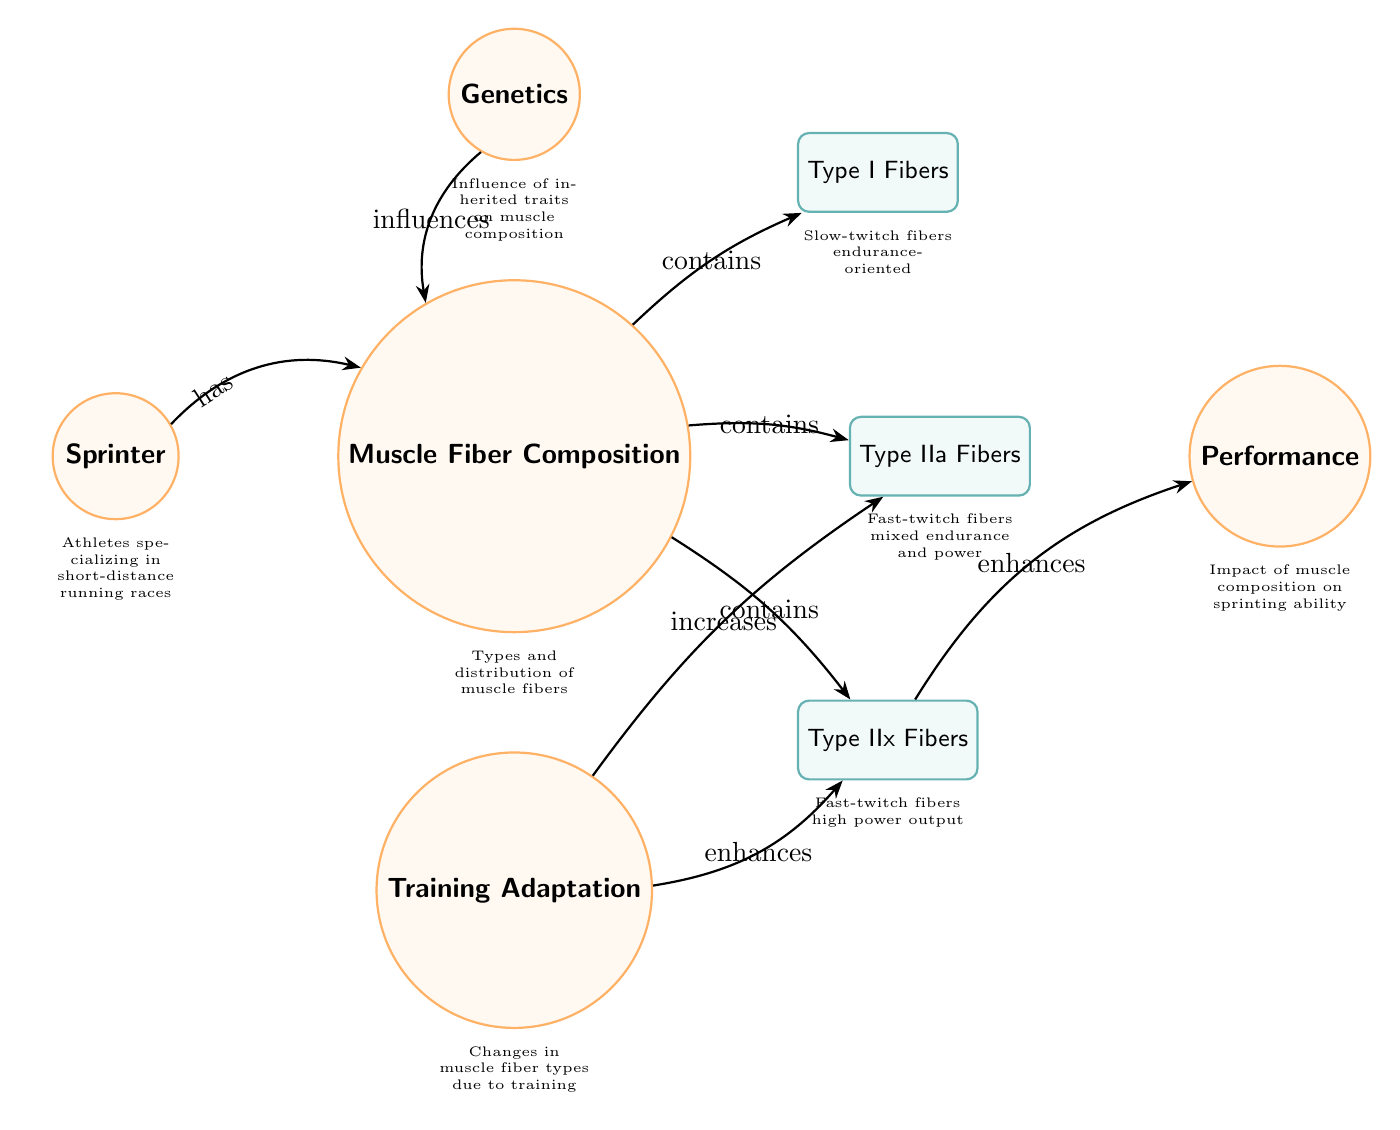What type of fibers are characterized as slow-twitch? The diagram specifically labels Type I fibers as "Slow-twitch fibers, endurance-oriented." This information can be directly found in the sub node labeled type_I.
Answer: Type I Fibers How many types of muscle fibers are shown in the diagram? The diagram lists three types of muscle fibers: Type I, Type IIa, and Type IIx. Thus, by counting the sub nodes connected to muscle fiber composition, we arrive at the number three.
Answer: 3 What influences muscle fiber composition according to the diagram? The diagram indicates that Genetics (the node labeled genetics) influences muscle fiber composition, as shown by the arrow pointing from the genetics node to the muscle fiber node.
Answer: Genetics Which type of fiber is associated with high power output? The diagram clearly indicates that Type IIx fibers are categorized as "Fast-twitch fibers, high power output," as noted in the sub node labeled type_IIx.
Answer: Type IIx Fibers How does training affect Type IIa fibers? According to the diagram, training increases Type IIa fibers, as shown by the arrow pointing from the training node to the Type IIa node. This indicates a positive relationship between the two.
Answer: Increases What is the connection between Type IIx fibers and performance? The diagram states that Type IIx fibers enhance performance, as depicted by the arrow from the type_IIx node to the performance node, denoting a beneficial impact on sprinting ability.
Answer: Enhances What is indicated as a factor contributing to performance in sprinters? The diagram shows that performance is influenced by Type IIx fibers, which enhances performance according to the connection made in the diagram.
Answer: Type IIx Fibers What type of training adapts muscle fibers according to the diagram? The diagram specifies that Training (labeled training) leads to changes in muscle fiber types, denoting it as a key factor for adaptations. Therefore, training is the method identified.
Answer: Training Which type of fibers serves a mixed purpose of endurance and power? The diagram identifies Type IIa fibers as "Fast-twitch fibers, mixed endurance and power," prominently establishing their dual role as indicated in the sub node.
Answer: Type IIa Fibers 